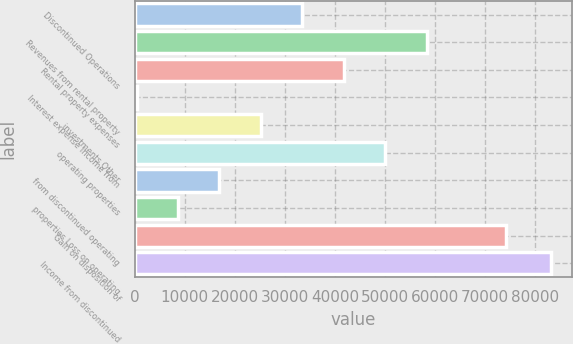Convert chart. <chart><loc_0><loc_0><loc_500><loc_500><bar_chart><fcel>Discontinued Operations<fcel>Revenues from rental property<fcel>Rental property expenses<fcel>Interest expense Income from<fcel>investments Other<fcel>operating properties<fcel>from discontinued operating<fcel>properties Loss on operating<fcel>Gain on disposition of<fcel>Income from discontinued<nl><fcel>33479.2<fcel>58303.6<fcel>41754<fcel>380<fcel>25204.4<fcel>50028.8<fcel>16929.6<fcel>8654.8<fcel>74138<fcel>83128<nl></chart> 